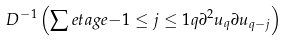<formula> <loc_0><loc_0><loc_500><loc_500>\ D ^ { - 1 } \left ( \sum e t a g e { - 1 \leq j \leq 1 } { q } \partial ^ { 2 } u _ { q } \partial u _ { q - j } \right )</formula> 